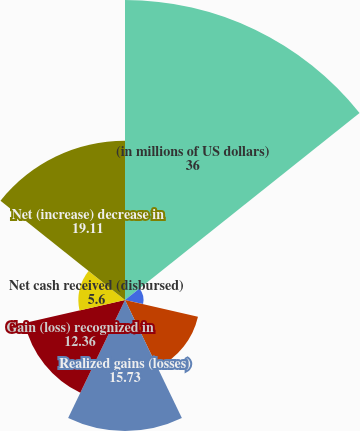<chart> <loc_0><loc_0><loc_500><loc_500><pie_chart><fcel>(in millions of US dollars)<fcel>Net premiums earned<fcel>Policy benefits<fcel>Realized gains (losses)<fcel>Gain (loss) recognized in<fcel>Net cash received (disbursed)<fcel>Net (increase) decrease in<nl><fcel>36.0%<fcel>2.22%<fcel>8.98%<fcel>15.73%<fcel>12.36%<fcel>5.6%<fcel>19.11%<nl></chart> 